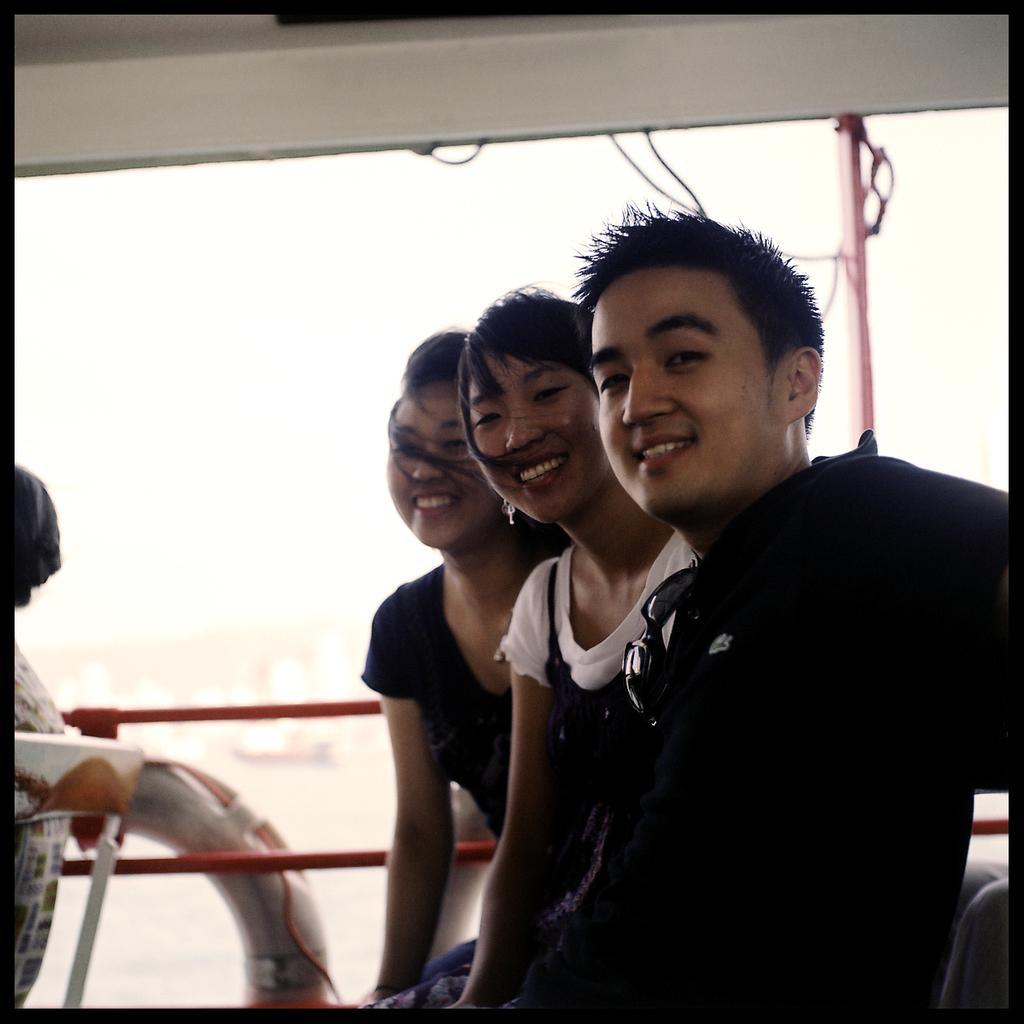Please provide a concise description of this image. In this image I can see the group of people with white and black color dresses. I think these people are sitting on the boat. And there is a white background. 